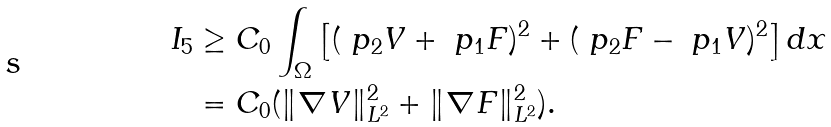<formula> <loc_0><loc_0><loc_500><loc_500>I _ { 5 } & \geq C _ { 0 } \int _ { \Omega } \left [ ( \ p _ { 2 } V + \ p _ { 1 } F ) ^ { 2 } + ( \ p _ { 2 } F - \ p _ { 1 } V ) ^ { 2 } \right ] d x \\ & = C _ { 0 } ( \| \nabla V \| _ { L ^ { 2 } } ^ { 2 } + \| \nabla F \| _ { L ^ { 2 } } ^ { 2 } ) .</formula> 